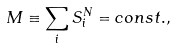<formula> <loc_0><loc_0><loc_500><loc_500>M \equiv \sum _ { i } S _ { i } ^ { N } = c o n s t . ,</formula> 